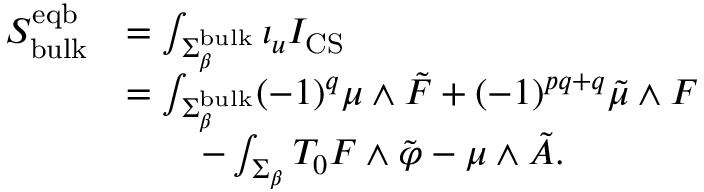<formula> <loc_0><loc_0><loc_500><loc_500>\begin{array} { r l } { S _ { b u l k } ^ { e q b } } & { = \int _ { \Sigma _ { \beta } ^ { b u l k } } \iota _ { u } I _ { C S } } \\ & { = \int _ { \Sigma _ { \beta } ^ { b u l k } } ( - 1 ) ^ { q } \mu \wedge \tilde { F } + ( - 1 ) ^ { p q + q } \tilde { \mu } \wedge F } \\ & { \quad - \int _ { \Sigma _ { \beta } } T _ { 0 } F \wedge \tilde { \varphi } - \mu \wedge \tilde { A } . } \end{array}</formula> 